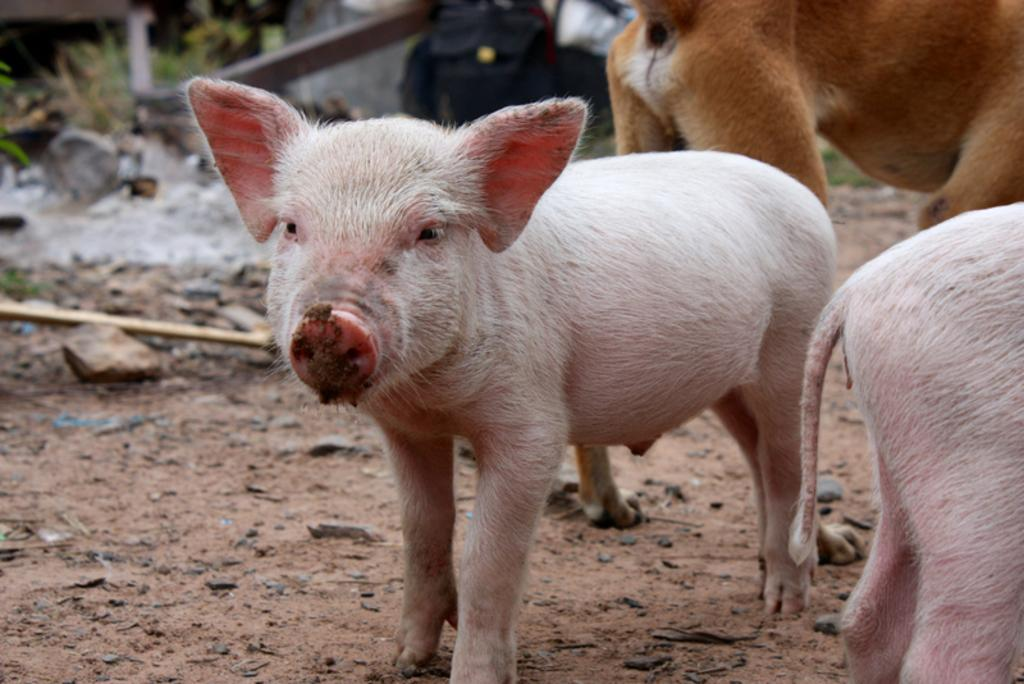What types of living organisms can be seen in the image? There are animals in the image. What is located at the bottom of the image? There are rocks at the bottom of the image. What type of vegetation is present in the image? Grass is present in the image. What type of desk can be seen in the image? There is no desk present in the image. Can you tell me how many stamps are on the animals in the image? There are no stamps on the animals in the image. 